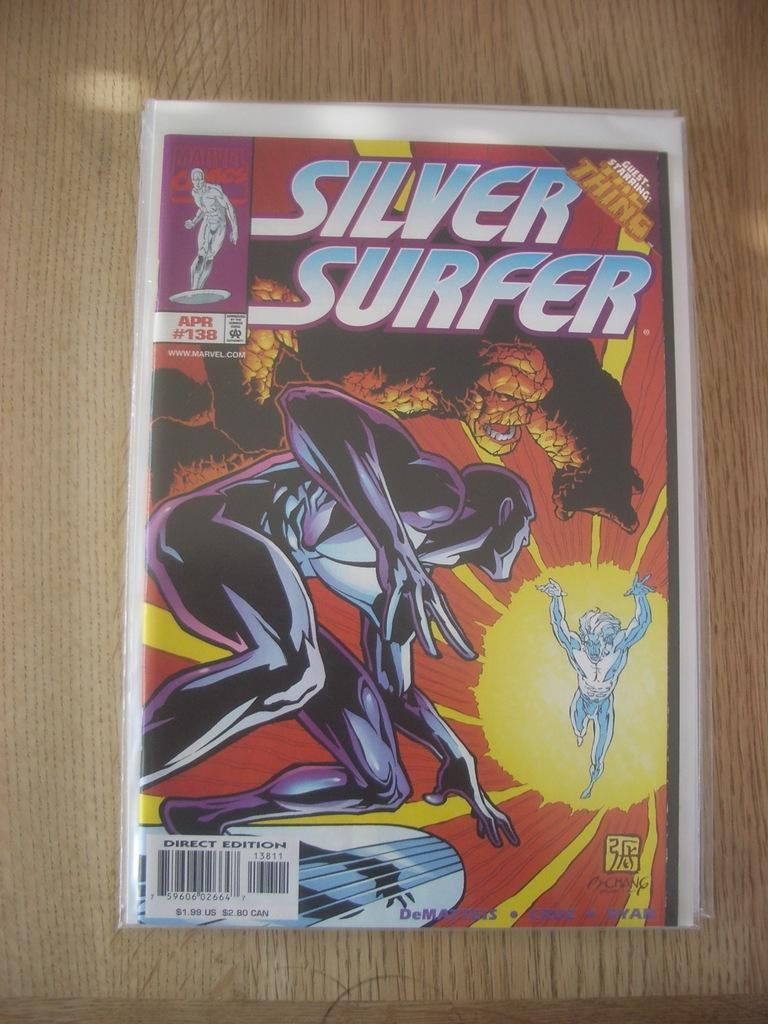<image>
Give a short and clear explanation of the subsequent image. An issue of Silver surfer is $1.99 in the US and $2.80 in Canada. 